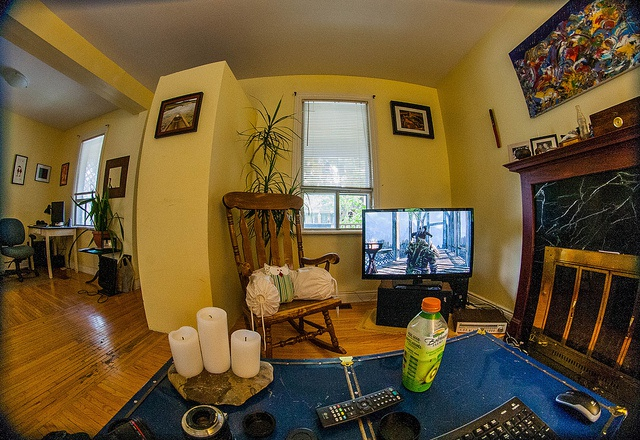Describe the objects in this image and their specific colors. I can see chair in black, maroon, and olive tones, chair in black, maroon, and olive tones, tv in black, lavender, lightblue, and darkgray tones, potted plant in black and olive tones, and bottle in black, olive, tan, and darkgreen tones in this image. 